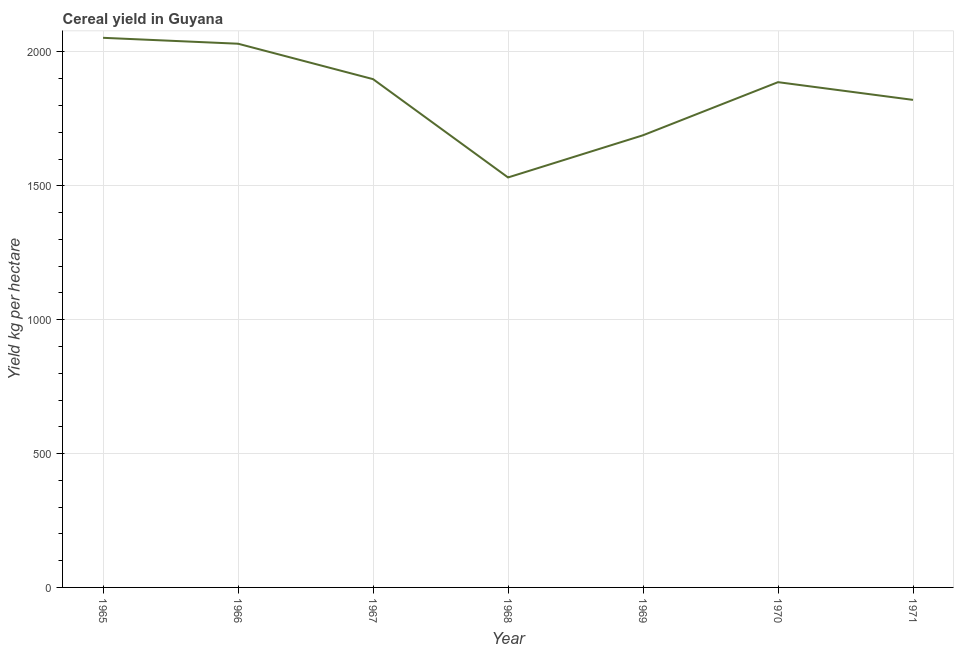What is the cereal yield in 1970?
Ensure brevity in your answer.  1887.22. Across all years, what is the maximum cereal yield?
Your answer should be very brief. 2052.88. Across all years, what is the minimum cereal yield?
Your answer should be very brief. 1531.28. In which year was the cereal yield maximum?
Your answer should be compact. 1965. In which year was the cereal yield minimum?
Give a very brief answer. 1968. What is the sum of the cereal yield?
Make the answer very short. 1.29e+04. What is the difference between the cereal yield in 1967 and 1969?
Provide a short and direct response. 209.63. What is the average cereal yield per year?
Provide a short and direct response. 1844.38. What is the median cereal yield?
Your answer should be compact. 1887.22. What is the ratio of the cereal yield in 1967 to that in 1968?
Ensure brevity in your answer.  1.24. Is the difference between the cereal yield in 1966 and 1970 greater than the difference between any two years?
Your answer should be very brief. No. What is the difference between the highest and the second highest cereal yield?
Provide a succinct answer. 22.06. Is the sum of the cereal yield in 1967 and 1968 greater than the maximum cereal yield across all years?
Provide a short and direct response. Yes. What is the difference between the highest and the lowest cereal yield?
Your answer should be compact. 521.6. How many lines are there?
Your answer should be compact. 1. What is the difference between two consecutive major ticks on the Y-axis?
Your answer should be compact. 500. Are the values on the major ticks of Y-axis written in scientific E-notation?
Offer a terse response. No. Does the graph contain grids?
Offer a very short reply. Yes. What is the title of the graph?
Your answer should be very brief. Cereal yield in Guyana. What is the label or title of the Y-axis?
Give a very brief answer. Yield kg per hectare. What is the Yield kg per hectare in 1965?
Provide a short and direct response. 2052.88. What is the Yield kg per hectare in 1966?
Provide a short and direct response. 2030.82. What is the Yield kg per hectare in 1967?
Provide a short and direct response. 1898.52. What is the Yield kg per hectare in 1968?
Offer a very short reply. 1531.28. What is the Yield kg per hectare in 1969?
Make the answer very short. 1688.88. What is the Yield kg per hectare of 1970?
Ensure brevity in your answer.  1887.22. What is the Yield kg per hectare in 1971?
Keep it short and to the point. 1821.04. What is the difference between the Yield kg per hectare in 1965 and 1966?
Keep it short and to the point. 22.07. What is the difference between the Yield kg per hectare in 1965 and 1967?
Keep it short and to the point. 154.37. What is the difference between the Yield kg per hectare in 1965 and 1968?
Provide a succinct answer. 521.6. What is the difference between the Yield kg per hectare in 1965 and 1969?
Provide a succinct answer. 364. What is the difference between the Yield kg per hectare in 1965 and 1970?
Make the answer very short. 165.67. What is the difference between the Yield kg per hectare in 1965 and 1971?
Offer a terse response. 231.84. What is the difference between the Yield kg per hectare in 1966 and 1967?
Your answer should be compact. 132.3. What is the difference between the Yield kg per hectare in 1966 and 1968?
Provide a succinct answer. 499.54. What is the difference between the Yield kg per hectare in 1966 and 1969?
Your answer should be compact. 341.93. What is the difference between the Yield kg per hectare in 1966 and 1970?
Provide a succinct answer. 143.6. What is the difference between the Yield kg per hectare in 1966 and 1971?
Offer a terse response. 209.78. What is the difference between the Yield kg per hectare in 1967 and 1968?
Make the answer very short. 367.23. What is the difference between the Yield kg per hectare in 1967 and 1969?
Your answer should be very brief. 209.63. What is the difference between the Yield kg per hectare in 1967 and 1970?
Your answer should be very brief. 11.3. What is the difference between the Yield kg per hectare in 1967 and 1971?
Keep it short and to the point. 77.47. What is the difference between the Yield kg per hectare in 1968 and 1969?
Your answer should be compact. -157.6. What is the difference between the Yield kg per hectare in 1968 and 1970?
Offer a terse response. -355.94. What is the difference between the Yield kg per hectare in 1968 and 1971?
Your response must be concise. -289.76. What is the difference between the Yield kg per hectare in 1969 and 1970?
Make the answer very short. -198.33. What is the difference between the Yield kg per hectare in 1969 and 1971?
Your answer should be compact. -132.16. What is the difference between the Yield kg per hectare in 1970 and 1971?
Your answer should be compact. 66.18. What is the ratio of the Yield kg per hectare in 1965 to that in 1966?
Keep it short and to the point. 1.01. What is the ratio of the Yield kg per hectare in 1965 to that in 1967?
Provide a short and direct response. 1.08. What is the ratio of the Yield kg per hectare in 1965 to that in 1968?
Provide a short and direct response. 1.34. What is the ratio of the Yield kg per hectare in 1965 to that in 1969?
Ensure brevity in your answer.  1.22. What is the ratio of the Yield kg per hectare in 1965 to that in 1970?
Provide a short and direct response. 1.09. What is the ratio of the Yield kg per hectare in 1965 to that in 1971?
Provide a short and direct response. 1.13. What is the ratio of the Yield kg per hectare in 1966 to that in 1967?
Your answer should be very brief. 1.07. What is the ratio of the Yield kg per hectare in 1966 to that in 1968?
Offer a very short reply. 1.33. What is the ratio of the Yield kg per hectare in 1966 to that in 1969?
Your response must be concise. 1.2. What is the ratio of the Yield kg per hectare in 1966 to that in 1970?
Ensure brevity in your answer.  1.08. What is the ratio of the Yield kg per hectare in 1966 to that in 1971?
Give a very brief answer. 1.11. What is the ratio of the Yield kg per hectare in 1967 to that in 1968?
Make the answer very short. 1.24. What is the ratio of the Yield kg per hectare in 1967 to that in 1969?
Your response must be concise. 1.12. What is the ratio of the Yield kg per hectare in 1967 to that in 1971?
Your answer should be compact. 1.04. What is the ratio of the Yield kg per hectare in 1968 to that in 1969?
Offer a terse response. 0.91. What is the ratio of the Yield kg per hectare in 1968 to that in 1970?
Keep it short and to the point. 0.81. What is the ratio of the Yield kg per hectare in 1968 to that in 1971?
Provide a succinct answer. 0.84. What is the ratio of the Yield kg per hectare in 1969 to that in 1970?
Offer a terse response. 0.9. What is the ratio of the Yield kg per hectare in 1969 to that in 1971?
Make the answer very short. 0.93. What is the ratio of the Yield kg per hectare in 1970 to that in 1971?
Provide a short and direct response. 1.04. 